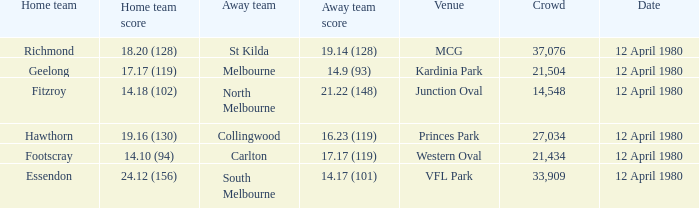Where did fitzroy play as the home team? Junction Oval. 